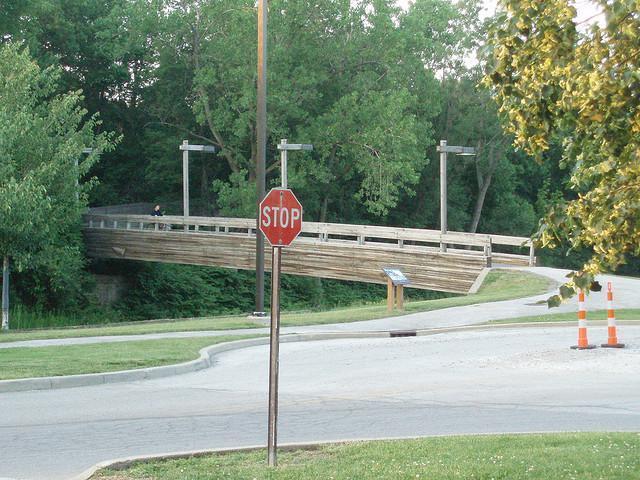How many orange cones are there?
Give a very brief answer. 2. How many oranges can be seen in the bottom box?
Give a very brief answer. 0. 